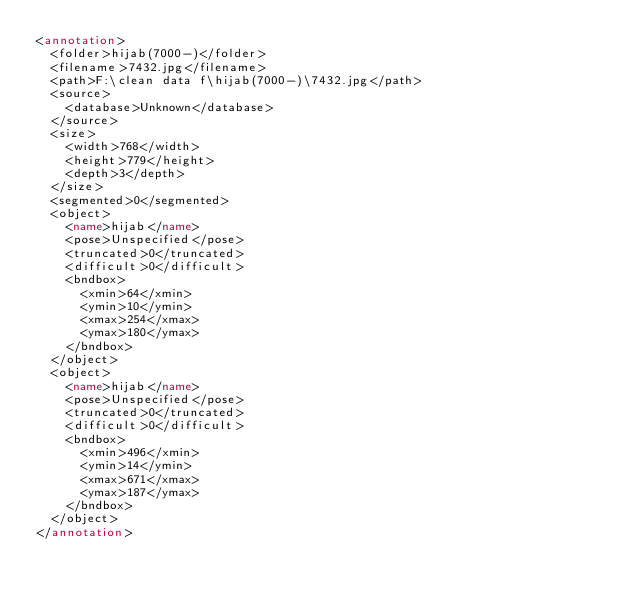Convert code to text. <code><loc_0><loc_0><loc_500><loc_500><_XML_><annotation>
	<folder>hijab(7000-)</folder>
	<filename>7432.jpg</filename>
	<path>F:\clean data f\hijab(7000-)\7432.jpg</path>
	<source>
		<database>Unknown</database>
	</source>
	<size>
		<width>768</width>
		<height>779</height>
		<depth>3</depth>
	</size>
	<segmented>0</segmented>
	<object>
		<name>hijab</name>
		<pose>Unspecified</pose>
		<truncated>0</truncated>
		<difficult>0</difficult>
		<bndbox>
			<xmin>64</xmin>
			<ymin>10</ymin>
			<xmax>254</xmax>
			<ymax>180</ymax>
		</bndbox>
	</object>
	<object>
		<name>hijab</name>
		<pose>Unspecified</pose>
		<truncated>0</truncated>
		<difficult>0</difficult>
		<bndbox>
			<xmin>496</xmin>
			<ymin>14</ymin>
			<xmax>671</xmax>
			<ymax>187</ymax>
		</bndbox>
	</object>
</annotation>
</code> 